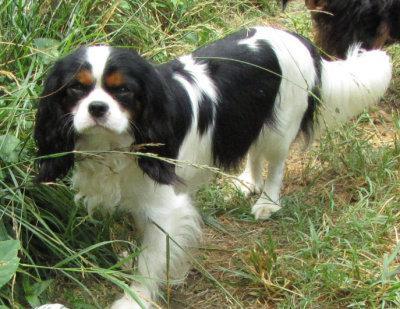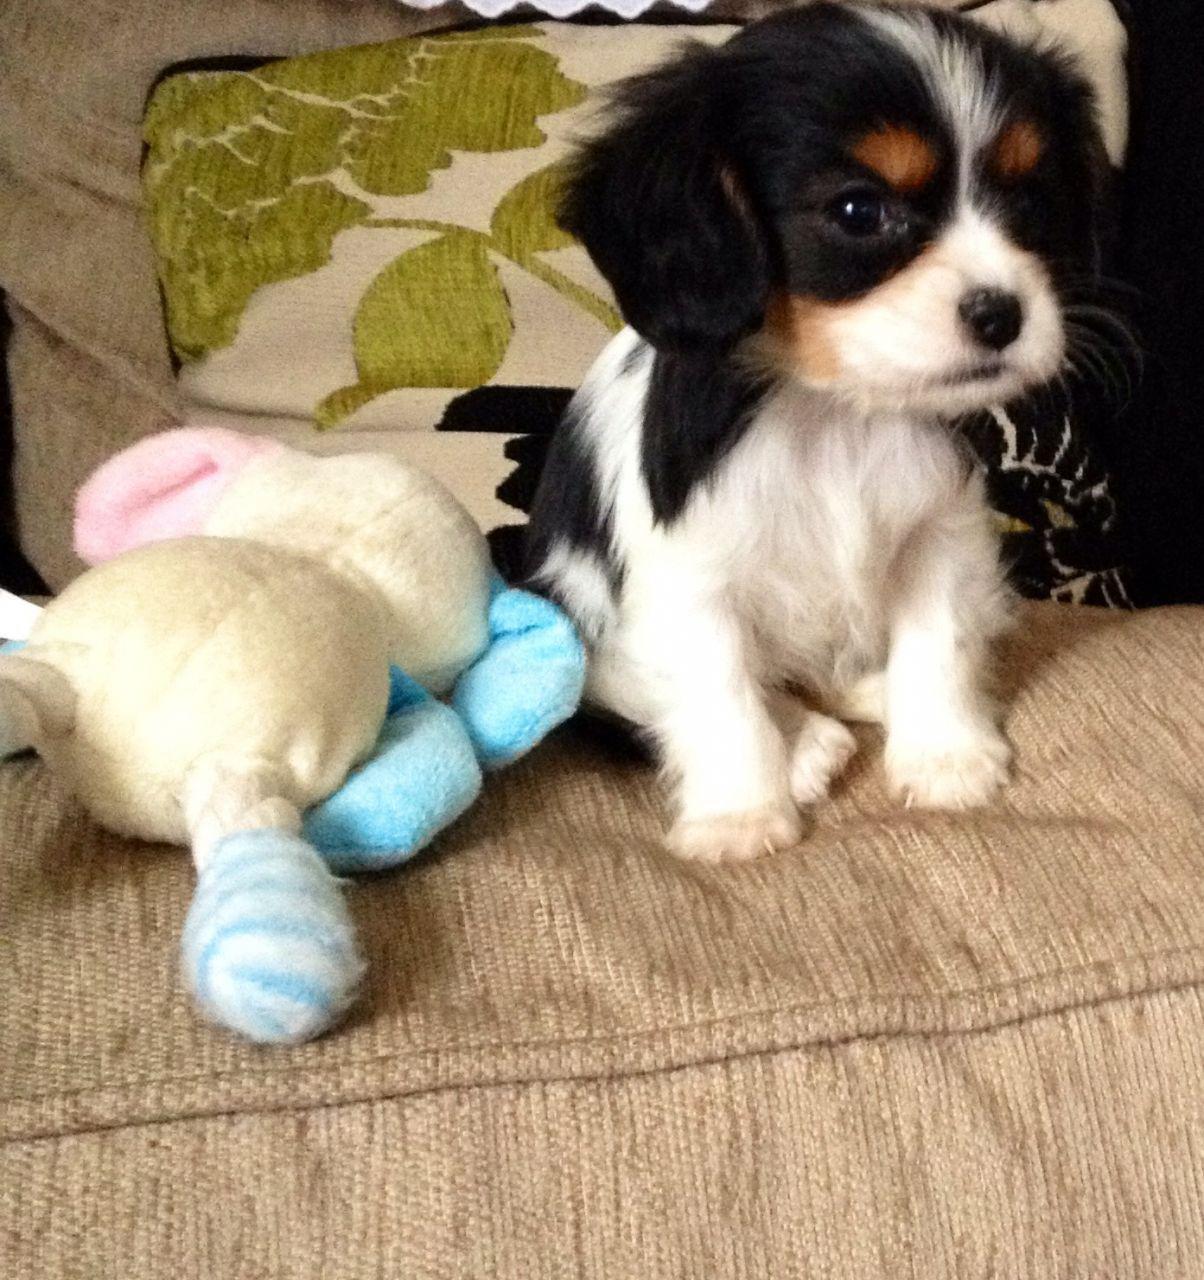The first image is the image on the left, the second image is the image on the right. Assess this claim about the two images: "At least two dogs are lying down in the image on the right.". Correct or not? Answer yes or no. No. The first image is the image on the left, the second image is the image on the right. Given the left and right images, does the statement "There are no less than six cocker spaniels" hold true? Answer yes or no. No. 